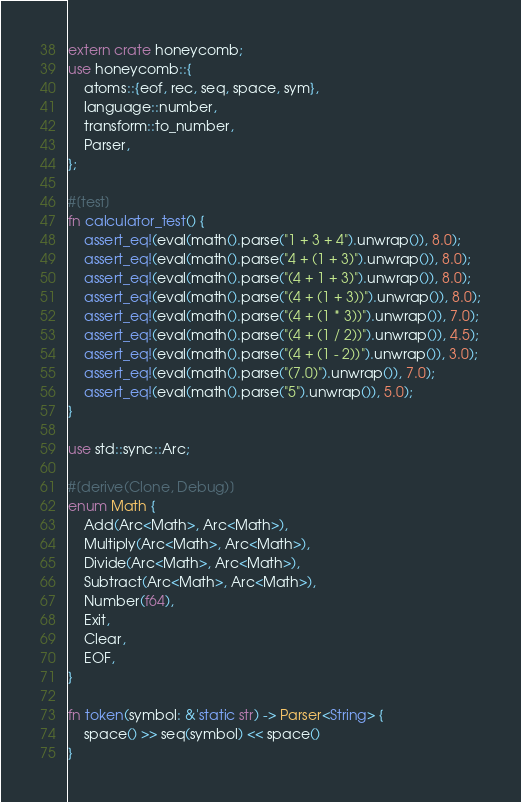<code> <loc_0><loc_0><loc_500><loc_500><_Rust_>extern crate honeycomb;
use honeycomb::{
    atoms::{eof, rec, seq, space, sym},
    language::number,
    transform::to_number,
    Parser,
};

#[test]
fn calculator_test() {
    assert_eq!(eval(math().parse("1 + 3 + 4").unwrap()), 8.0);
    assert_eq!(eval(math().parse("4 + (1 + 3)").unwrap()), 8.0);
    assert_eq!(eval(math().parse("(4 + 1 + 3)").unwrap()), 8.0);
    assert_eq!(eval(math().parse("(4 + (1 + 3))").unwrap()), 8.0);
    assert_eq!(eval(math().parse("(4 + (1 * 3))").unwrap()), 7.0);
    assert_eq!(eval(math().parse("(4 + (1 / 2))").unwrap()), 4.5);
    assert_eq!(eval(math().parse("(4 + (1 - 2))").unwrap()), 3.0);
    assert_eq!(eval(math().parse("(7.0)").unwrap()), 7.0);
    assert_eq!(eval(math().parse("5").unwrap()), 5.0);
}

use std::sync::Arc;

#[derive(Clone, Debug)]
enum Math {
    Add(Arc<Math>, Arc<Math>),
    Multiply(Arc<Math>, Arc<Math>),
    Divide(Arc<Math>, Arc<Math>),
    Subtract(Arc<Math>, Arc<Math>),
    Number(f64),
    Exit,
    Clear,
    EOF,
}

fn token(symbol: &'static str) -> Parser<String> {
    space() >> seq(symbol) << space()
}
</code> 